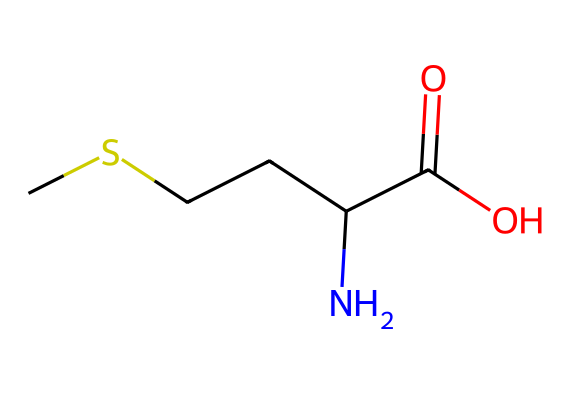What is the molecular formula of this compound? The SMILES representation indicates there are 5 carbon atoms (C), 11 hydrogen atoms (H), 1 nitrogen atom (N), and 2 oxygen atoms (O) in the compound. Therefore, the molecular formula can be derived as C5H11NO2.
Answer: C5H11NO2 How many chiral centers are present in this compound? In the given SMILES structure, a chiral center is typically indicated by a carbon atom bonded to four different substituents. Inspecting the structure shows there is one carbon atom adjacent to the amino group (NH2) and the carboxylic acid (COOH), indicating it is chiral.
Answer: 1 What functional groups are present in this molecule? The SMILES notation reveals two significant functional groups: the amino group (NH2) and the carboxylic acid group (COOH). Both groups play key roles in the biological activity of amino acids.
Answer: amino and carboxylic acid Which element is uniquely identified as present in this organosulfur compound? The presence of a sulfur atom is necessary to categorize a compound as an organosulfur compound. However, this specific amino acid (methionine) also contains sulfur as part of its side chain, making it significant in biological contexts.
Answer: sulfur What is the role of this compound in protein synthesis? Methionine serves as the initiating amino acid in the protein synthesis process, often marked as the first amino acid incorporated during translation, linking it directly to protein formation.
Answer: initiating amino acid How many hydrogen atoms are directly bonded to the nitrogen atom in this structure? The SMILES representation shows that the nitrogen atom has two hydrogen atoms directly bonded to it as part of the amino group (NH2), thereby determining its basicity and involvement in protein structure.
Answer: 2 